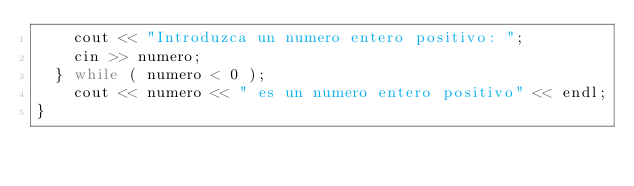Convert code to text. <code><loc_0><loc_0><loc_500><loc_500><_C++_>		cout << "Introduzca un numero entero positivo: ";
		cin >> numero;
	} while ( numero < 0 );
		cout << numero << " es un numero entero positivo" << endl;
}
</code> 